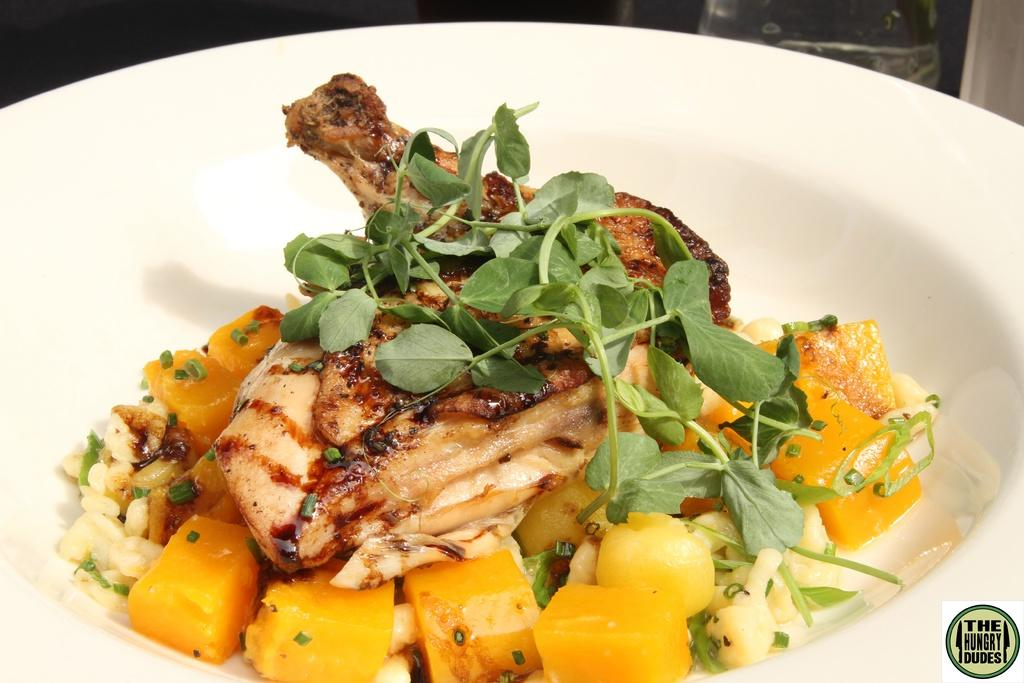What colors can be seen in the food in the image? The food in the image has yellow, brown, green, and cream colors. What type of container is the food in? The food is in a bowl. What color is the bowl? The bowl is white in color. What type of jewel is hidden in the bowl of food? There is no jewel present in the bowl of food; it contains only food. 